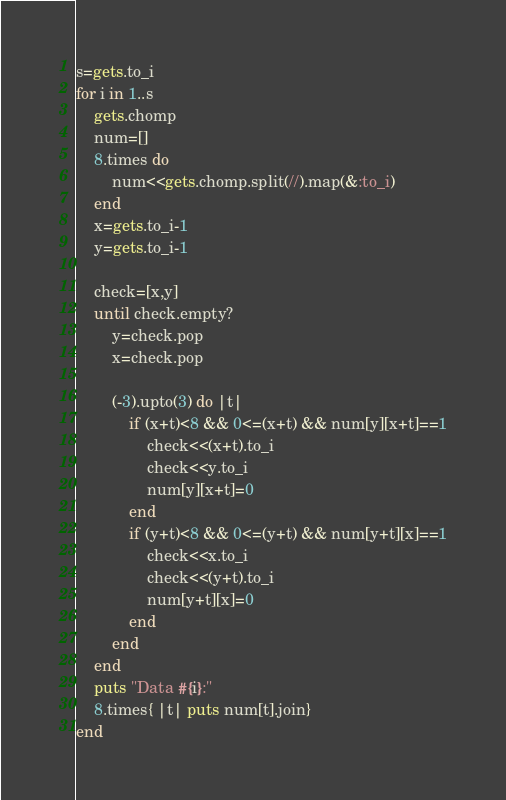<code> <loc_0><loc_0><loc_500><loc_500><_Ruby_>s=gets.to_i
for i in 1..s
    gets.chomp
    num=[]
    8.times do
        num<<gets.chomp.split(//).map(&:to_i)
    end
    x=gets.to_i-1
    y=gets.to_i-1
    
    check=[x,y]
    until check.empty?
        y=check.pop
        x=check.pop
        
        (-3).upto(3) do |t|
            if (x+t)<8 && 0<=(x+t) && num[y][x+t]==1
                check<<(x+t).to_i
                check<<y.to_i
                num[y][x+t]=0
            end
            if (y+t)<8 && 0<=(y+t) && num[y+t][x]==1
                check<<x.to_i
                check<<(y+t).to_i
                num[y+t][x]=0
            end
        end
    end
    puts "Data #{i}:"
    8.times{ |t| puts num[t].join}
end</code> 